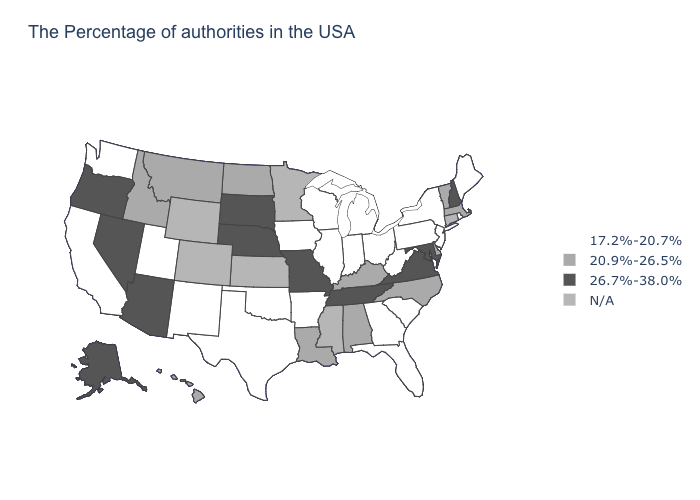What is the value of Delaware?
Keep it brief. 20.9%-26.5%. What is the highest value in the USA?
Concise answer only. 26.7%-38.0%. Is the legend a continuous bar?
Answer briefly. No. Name the states that have a value in the range 26.7%-38.0%?
Give a very brief answer. New Hampshire, Maryland, Virginia, Tennessee, Missouri, Nebraska, South Dakota, Arizona, Nevada, Oregon, Alaska. Which states have the lowest value in the USA?
Give a very brief answer. Maine, Rhode Island, New York, New Jersey, Pennsylvania, South Carolina, West Virginia, Ohio, Florida, Georgia, Michigan, Indiana, Wisconsin, Illinois, Arkansas, Iowa, Oklahoma, Texas, New Mexico, Utah, California, Washington. Name the states that have a value in the range 20.9%-26.5%?
Write a very short answer. Massachusetts, Vermont, Delaware, North Carolina, Kentucky, Alabama, Louisiana, North Dakota, Montana, Idaho, Hawaii. Is the legend a continuous bar?
Be succinct. No. How many symbols are there in the legend?
Keep it brief. 4. Among the states that border North Dakota , does South Dakota have the highest value?
Concise answer only. Yes. What is the highest value in the USA?
Short answer required. 26.7%-38.0%. What is the value of Tennessee?
Short answer required. 26.7%-38.0%. What is the value of South Dakota?
Give a very brief answer. 26.7%-38.0%. Name the states that have a value in the range 17.2%-20.7%?
Quick response, please. Maine, Rhode Island, New York, New Jersey, Pennsylvania, South Carolina, West Virginia, Ohio, Florida, Georgia, Michigan, Indiana, Wisconsin, Illinois, Arkansas, Iowa, Oklahoma, Texas, New Mexico, Utah, California, Washington. Which states have the highest value in the USA?
Answer briefly. New Hampshire, Maryland, Virginia, Tennessee, Missouri, Nebraska, South Dakota, Arizona, Nevada, Oregon, Alaska. 